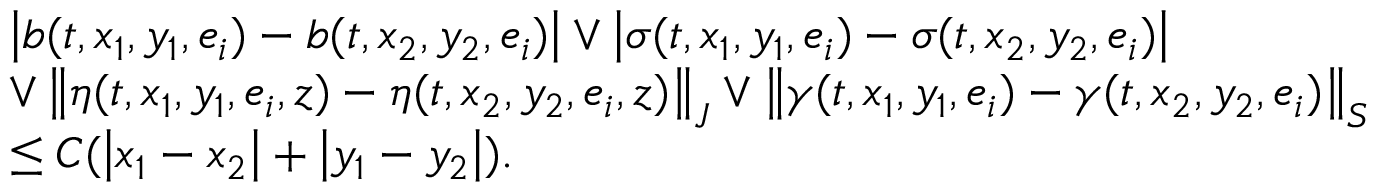<formula> <loc_0><loc_0><loc_500><loc_500>\begin{array} { r l } & { \left | b ( t , x _ { 1 } , y _ { 1 } , e _ { i } ) - b ( t , x _ { 2 } , y _ { 2 } , e _ { i } ) \right | \vee \left | \sigma ( t , x _ { 1 } , y _ { 1 } , e _ { i } ) - \sigma ( t , x _ { 2 } , y _ { 2 } , e _ { i } ) \right | } \\ & { \vee \left \| \eta ( t , x _ { 1 } , y _ { 1 } , e _ { i } , z ) - \eta ( t , x _ { 2 } , y _ { 2 } , e _ { i } , z ) \right \| _ { J } \vee \left \| \gamma ( t , x _ { 1 } , y _ { 1 } , e _ { i } ) - \gamma ( t , x _ { 2 } , y _ { 2 } , e _ { i } ) \right \| _ { S } } \\ & { \leq C ( \left | x _ { 1 } - x _ { 2 } \right | + \left | y _ { 1 } - y _ { 2 } \right | ) . } \end{array}</formula> 